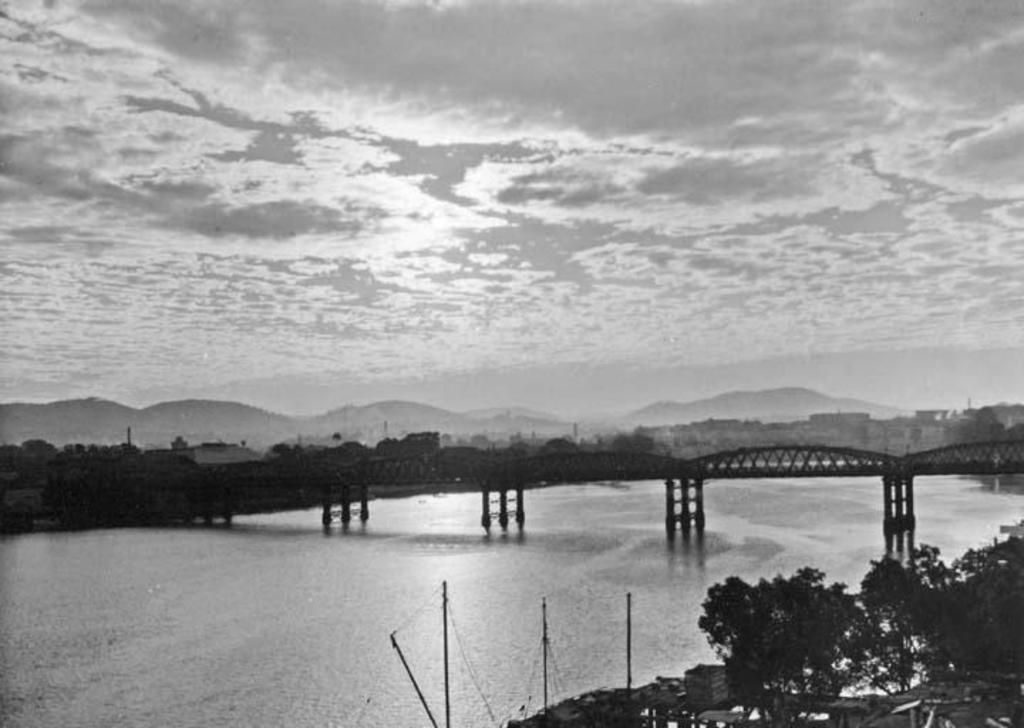Please provide a concise description of this image. In this picture we can see a bridge, under this bridge we can see water, here we can see buildings, trees and some objects and in the background we can see mountains, sky. 